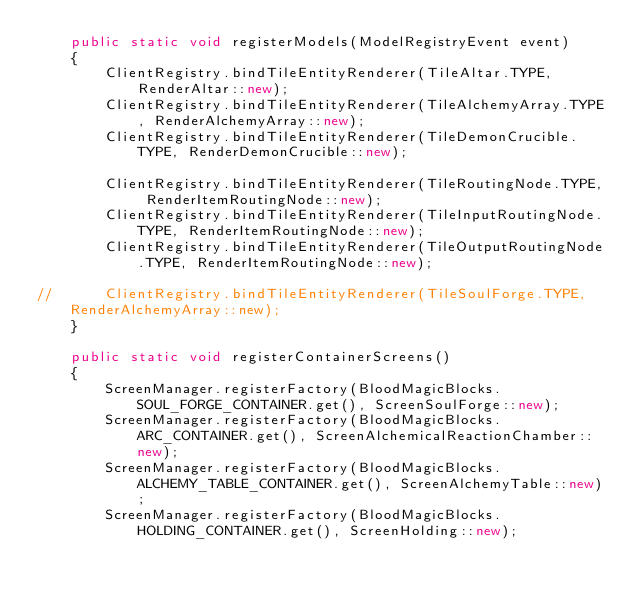Convert code to text. <code><loc_0><loc_0><loc_500><loc_500><_Java_>	public static void registerModels(ModelRegistryEvent event)
	{
		ClientRegistry.bindTileEntityRenderer(TileAltar.TYPE, RenderAltar::new);
		ClientRegistry.bindTileEntityRenderer(TileAlchemyArray.TYPE, RenderAlchemyArray::new);
		ClientRegistry.bindTileEntityRenderer(TileDemonCrucible.TYPE, RenderDemonCrucible::new);

		ClientRegistry.bindTileEntityRenderer(TileRoutingNode.TYPE, RenderItemRoutingNode::new);
		ClientRegistry.bindTileEntityRenderer(TileInputRoutingNode.TYPE, RenderItemRoutingNode::new);
		ClientRegistry.bindTileEntityRenderer(TileOutputRoutingNode.TYPE, RenderItemRoutingNode::new);

//		ClientRegistry.bindTileEntityRenderer(TileSoulForge.TYPE, RenderAlchemyArray::new);
	}

	public static void registerContainerScreens()
	{
		ScreenManager.registerFactory(BloodMagicBlocks.SOUL_FORGE_CONTAINER.get(), ScreenSoulForge::new);
		ScreenManager.registerFactory(BloodMagicBlocks.ARC_CONTAINER.get(), ScreenAlchemicalReactionChamber::new);
		ScreenManager.registerFactory(BloodMagicBlocks.ALCHEMY_TABLE_CONTAINER.get(), ScreenAlchemyTable::new);
		ScreenManager.registerFactory(BloodMagicBlocks.HOLDING_CONTAINER.get(), ScreenHolding::new);</code> 